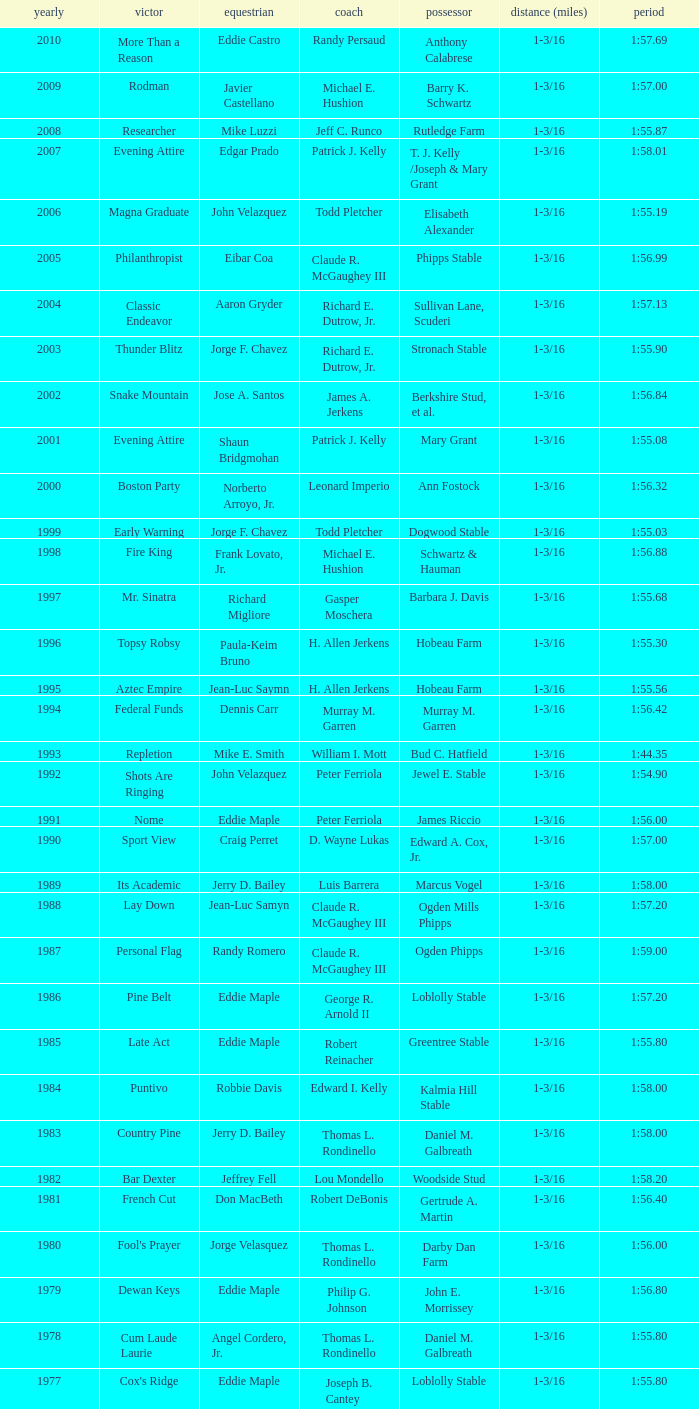What was the time for the winning horse Salford ii? 1:44.20. 